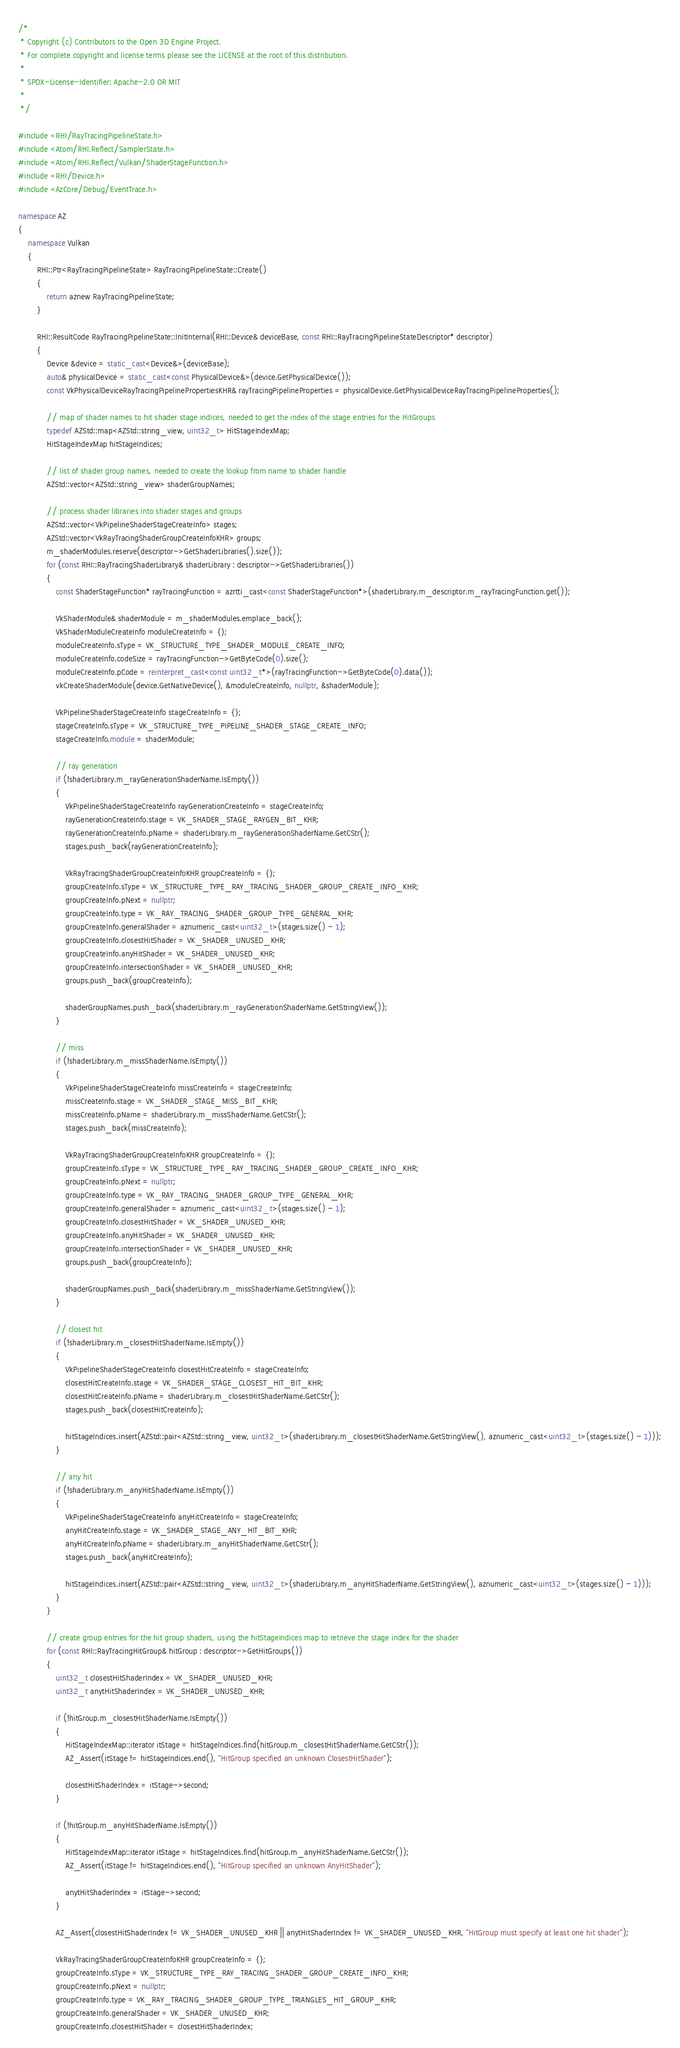Convert code to text. <code><loc_0><loc_0><loc_500><loc_500><_C++_>/*
 * Copyright (c) Contributors to the Open 3D Engine Project.
 * For complete copyright and license terms please see the LICENSE at the root of this distribution.
 *
 * SPDX-License-Identifier: Apache-2.0 OR MIT
 *
 */

#include <RHI/RayTracingPipelineState.h>
#include <Atom/RHI.Reflect/SamplerState.h>
#include <Atom/RHI.Reflect/Vulkan/ShaderStageFunction.h>
#include <RHI/Device.h>
#include <AzCore/Debug/EventTrace.h>

namespace AZ
{
    namespace Vulkan
    {
        RHI::Ptr<RayTracingPipelineState> RayTracingPipelineState::Create()
        {
            return aznew RayTracingPipelineState;
        }

        RHI::ResultCode RayTracingPipelineState::InitInternal(RHI::Device& deviceBase, const RHI::RayTracingPipelineStateDescriptor* descriptor)
        {
            Device &device = static_cast<Device&>(deviceBase);
            auto& physicalDevice = static_cast<const PhysicalDevice&>(device.GetPhysicalDevice());
            const VkPhysicalDeviceRayTracingPipelinePropertiesKHR& rayTracingPipelineProperties = physicalDevice.GetPhysicalDeviceRayTracingPipelineProperties();

            // map of shader names to hit shader stage indices, needed to get the index of the stage entries for the HitGroups
            typedef AZStd::map<AZStd::string_view, uint32_t> HitStageIndexMap;
            HitStageIndexMap hitStageIndices;

            // list of shader group names, needed to create the lookup from name to shader handle
            AZStd::vector<AZStd::string_view> shaderGroupNames;

            // process shader libraries into shader stages and groups
            AZStd::vector<VkPipelineShaderStageCreateInfo> stages;
            AZStd::vector<VkRayTracingShaderGroupCreateInfoKHR> groups;
            m_shaderModules.reserve(descriptor->GetShaderLibraries().size());
            for (const RHI::RayTracingShaderLibrary& shaderLibrary : descriptor->GetShaderLibraries())
            {
                const ShaderStageFunction* rayTracingFunction = azrtti_cast<const ShaderStageFunction*>(shaderLibrary.m_descriptor.m_rayTracingFunction.get());

                VkShaderModule& shaderModule = m_shaderModules.emplace_back();
                VkShaderModuleCreateInfo moduleCreateInfo = {};
                moduleCreateInfo.sType = VK_STRUCTURE_TYPE_SHADER_MODULE_CREATE_INFO;
                moduleCreateInfo.codeSize = rayTracingFunction->GetByteCode(0).size();
                moduleCreateInfo.pCode = reinterpret_cast<const uint32_t*>(rayTracingFunction->GetByteCode(0).data());
                vkCreateShaderModule(device.GetNativeDevice(), &moduleCreateInfo, nullptr, &shaderModule);

                VkPipelineShaderStageCreateInfo stageCreateInfo = {};
                stageCreateInfo.sType = VK_STRUCTURE_TYPE_PIPELINE_SHADER_STAGE_CREATE_INFO;
                stageCreateInfo.module = shaderModule;

                // ray generation
                if (!shaderLibrary.m_rayGenerationShaderName.IsEmpty())
                {
                    VkPipelineShaderStageCreateInfo rayGenerationCreateInfo = stageCreateInfo;
                    rayGenerationCreateInfo.stage = VK_SHADER_STAGE_RAYGEN_BIT_KHR;
                    rayGenerationCreateInfo.pName = shaderLibrary.m_rayGenerationShaderName.GetCStr();
                    stages.push_back(rayGenerationCreateInfo);

                    VkRayTracingShaderGroupCreateInfoKHR groupCreateInfo = {};
                    groupCreateInfo.sType = VK_STRUCTURE_TYPE_RAY_TRACING_SHADER_GROUP_CREATE_INFO_KHR;
                    groupCreateInfo.pNext = nullptr;
                    groupCreateInfo.type = VK_RAY_TRACING_SHADER_GROUP_TYPE_GENERAL_KHR;
                    groupCreateInfo.generalShader = aznumeric_cast<uint32_t>(stages.size() - 1);
                    groupCreateInfo.closestHitShader = VK_SHADER_UNUSED_KHR;
                    groupCreateInfo.anyHitShader = VK_SHADER_UNUSED_KHR;
                    groupCreateInfo.intersectionShader = VK_SHADER_UNUSED_KHR;
                    groups.push_back(groupCreateInfo);

                    shaderGroupNames.push_back(shaderLibrary.m_rayGenerationShaderName.GetStringView());
                }

                // miss
                if (!shaderLibrary.m_missShaderName.IsEmpty())
                {
                    VkPipelineShaderStageCreateInfo missCreateInfo = stageCreateInfo;
                    missCreateInfo.stage = VK_SHADER_STAGE_MISS_BIT_KHR;
                    missCreateInfo.pName = shaderLibrary.m_missShaderName.GetCStr();
                    stages.push_back(missCreateInfo);

                    VkRayTracingShaderGroupCreateInfoKHR groupCreateInfo = {};
                    groupCreateInfo.sType = VK_STRUCTURE_TYPE_RAY_TRACING_SHADER_GROUP_CREATE_INFO_KHR;
                    groupCreateInfo.pNext = nullptr;
                    groupCreateInfo.type = VK_RAY_TRACING_SHADER_GROUP_TYPE_GENERAL_KHR;
                    groupCreateInfo.generalShader = aznumeric_cast<uint32_t>(stages.size() - 1);
                    groupCreateInfo.closestHitShader = VK_SHADER_UNUSED_KHR;
                    groupCreateInfo.anyHitShader = VK_SHADER_UNUSED_KHR;
                    groupCreateInfo.intersectionShader = VK_SHADER_UNUSED_KHR;
                    groups.push_back(groupCreateInfo);

                    shaderGroupNames.push_back(shaderLibrary.m_missShaderName.GetStringView());
                }

                // closest hit
                if (!shaderLibrary.m_closestHitShaderName.IsEmpty())
                {
                    VkPipelineShaderStageCreateInfo closestHitCreateInfo = stageCreateInfo;
                    closestHitCreateInfo.stage = VK_SHADER_STAGE_CLOSEST_HIT_BIT_KHR;
                    closestHitCreateInfo.pName = shaderLibrary.m_closestHitShaderName.GetCStr();
                    stages.push_back(closestHitCreateInfo);

                    hitStageIndices.insert(AZStd::pair<AZStd::string_view, uint32_t>(shaderLibrary.m_closestHitShaderName.GetStringView(), aznumeric_cast<uint32_t>(stages.size() - 1)));
                }

                // any hit
                if (!shaderLibrary.m_anyHitShaderName.IsEmpty())
                {
                    VkPipelineShaderStageCreateInfo anyHitCreateInfo = stageCreateInfo;
                    anyHitCreateInfo.stage = VK_SHADER_STAGE_ANY_HIT_BIT_KHR;
                    anyHitCreateInfo.pName = shaderLibrary.m_anyHitShaderName.GetCStr();
                    stages.push_back(anyHitCreateInfo);

                    hitStageIndices.insert(AZStd::pair<AZStd::string_view, uint32_t>(shaderLibrary.m_anyHitShaderName.GetStringView(), aznumeric_cast<uint32_t>(stages.size() - 1)));
                }
            }

            // create group entries for the hit group shaders, using the hitStageIndices map to retrieve the stage index for the shader
            for (const RHI::RayTracingHitGroup& hitGroup : descriptor->GetHitGroups())
            {
                uint32_t closestHitShaderIndex = VK_SHADER_UNUSED_KHR;
                uint32_t anytHitShaderIndex = VK_SHADER_UNUSED_KHR;

                if (!hitGroup.m_closestHitShaderName.IsEmpty())
                {
                    HitStageIndexMap::iterator itStage = hitStageIndices.find(hitGroup.m_closestHitShaderName.GetCStr());
                    AZ_Assert(itStage != hitStageIndices.end(), "HitGroup specified an unknown ClosestHitShader");

                    closestHitShaderIndex = itStage->second;
                }

                if (!hitGroup.m_anyHitShaderName.IsEmpty())
                {
                    HitStageIndexMap::iterator itStage = hitStageIndices.find(hitGroup.m_anyHitShaderName.GetCStr());
                    AZ_Assert(itStage != hitStageIndices.end(), "HitGroup specified an unknown AnyHitShader");

                    anytHitShaderIndex = itStage->second;
                }

                AZ_Assert(closestHitShaderIndex != VK_SHADER_UNUSED_KHR || anytHitShaderIndex != VK_SHADER_UNUSED_KHR, "HitGroup must specify at least one hit shader");

                VkRayTracingShaderGroupCreateInfoKHR groupCreateInfo = {};
                groupCreateInfo.sType = VK_STRUCTURE_TYPE_RAY_TRACING_SHADER_GROUP_CREATE_INFO_KHR;
                groupCreateInfo.pNext = nullptr;
                groupCreateInfo.type = VK_RAY_TRACING_SHADER_GROUP_TYPE_TRIANGLES_HIT_GROUP_KHR;
                groupCreateInfo.generalShader = VK_SHADER_UNUSED_KHR;
                groupCreateInfo.closestHitShader = closestHitShaderIndex;</code> 